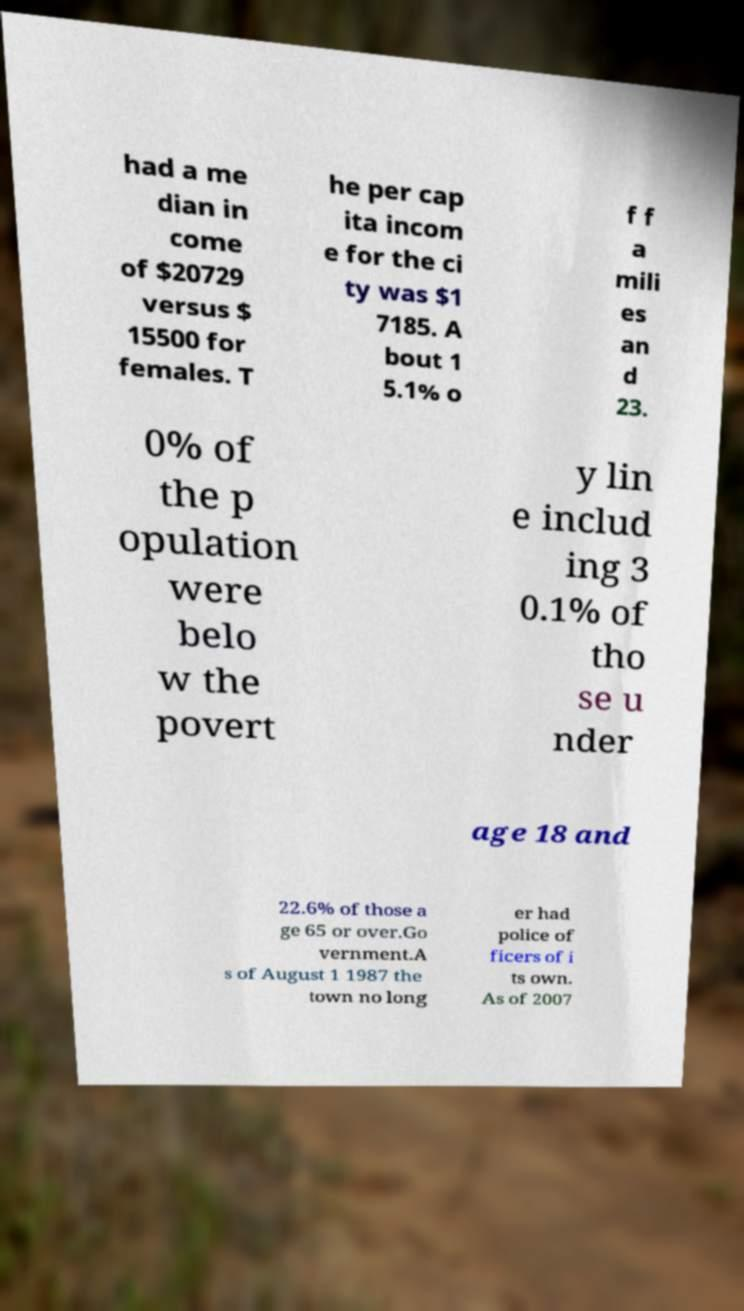Please identify and transcribe the text found in this image. had a me dian in come of $20729 versus $ 15500 for females. T he per cap ita incom e for the ci ty was $1 7185. A bout 1 5.1% o f f a mili es an d 23. 0% of the p opulation were belo w the povert y lin e includ ing 3 0.1% of tho se u nder age 18 and 22.6% of those a ge 65 or over.Go vernment.A s of August 1 1987 the town no long er had police of ficers of i ts own. As of 2007 